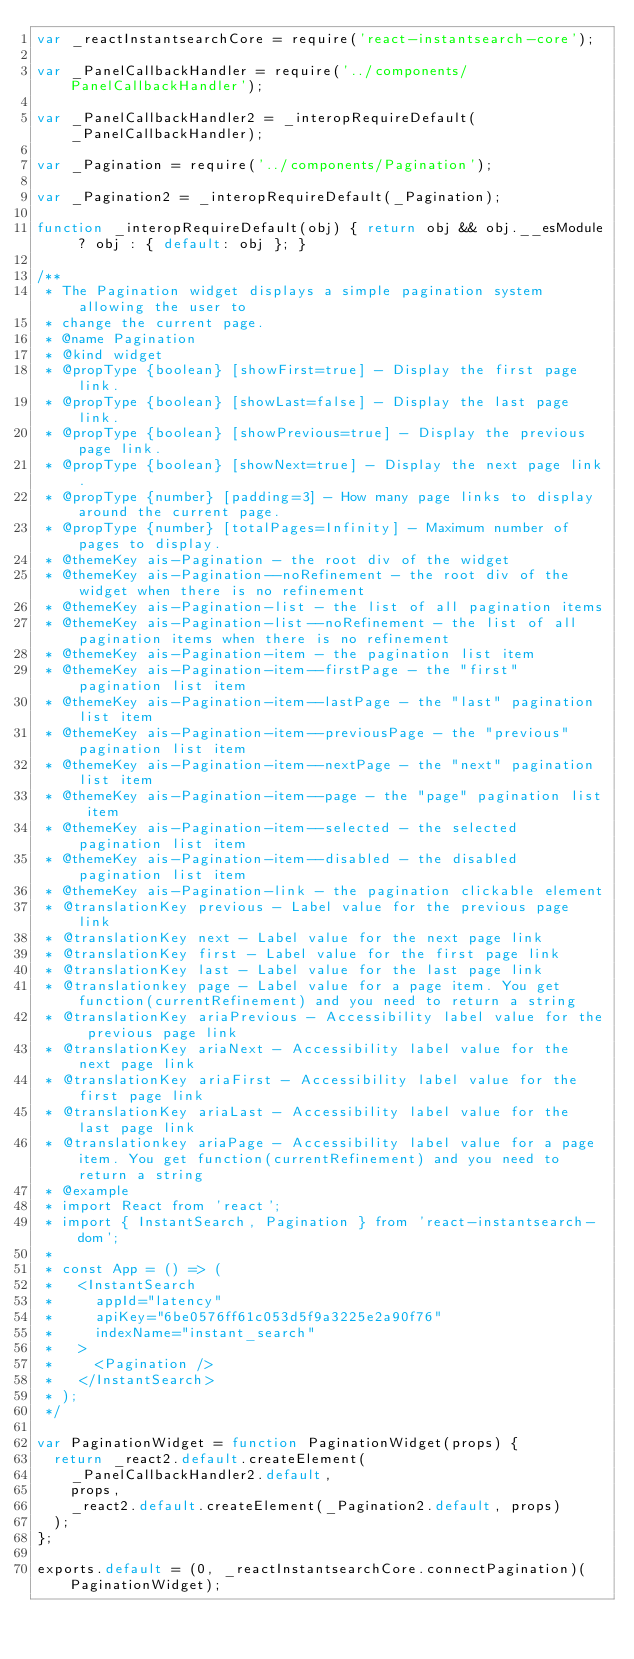Convert code to text. <code><loc_0><loc_0><loc_500><loc_500><_JavaScript_>var _reactInstantsearchCore = require('react-instantsearch-core');

var _PanelCallbackHandler = require('../components/PanelCallbackHandler');

var _PanelCallbackHandler2 = _interopRequireDefault(_PanelCallbackHandler);

var _Pagination = require('../components/Pagination');

var _Pagination2 = _interopRequireDefault(_Pagination);

function _interopRequireDefault(obj) { return obj && obj.__esModule ? obj : { default: obj }; }

/**
 * The Pagination widget displays a simple pagination system allowing the user to
 * change the current page.
 * @name Pagination
 * @kind widget
 * @propType {boolean} [showFirst=true] - Display the first page link.
 * @propType {boolean} [showLast=false] - Display the last page link.
 * @propType {boolean} [showPrevious=true] - Display the previous page link.
 * @propType {boolean} [showNext=true] - Display the next page link.
 * @propType {number} [padding=3] - How many page links to display around the current page.
 * @propType {number} [totalPages=Infinity] - Maximum number of pages to display.
 * @themeKey ais-Pagination - the root div of the widget
 * @themeKey ais-Pagination--noRefinement - the root div of the widget when there is no refinement
 * @themeKey ais-Pagination-list - the list of all pagination items
 * @themeKey ais-Pagination-list--noRefinement - the list of all pagination items when there is no refinement
 * @themeKey ais-Pagination-item - the pagination list item
 * @themeKey ais-Pagination-item--firstPage - the "first" pagination list item
 * @themeKey ais-Pagination-item--lastPage - the "last" pagination list item
 * @themeKey ais-Pagination-item--previousPage - the "previous" pagination list item
 * @themeKey ais-Pagination-item--nextPage - the "next" pagination list item
 * @themeKey ais-Pagination-item--page - the "page" pagination list item
 * @themeKey ais-Pagination-item--selected - the selected pagination list item
 * @themeKey ais-Pagination-item--disabled - the disabled pagination list item
 * @themeKey ais-Pagination-link - the pagination clickable element
 * @translationKey previous - Label value for the previous page link
 * @translationKey next - Label value for the next page link
 * @translationKey first - Label value for the first page link
 * @translationKey last - Label value for the last page link
 * @translationkey page - Label value for a page item. You get function(currentRefinement) and you need to return a string
 * @translationKey ariaPrevious - Accessibility label value for the previous page link
 * @translationKey ariaNext - Accessibility label value for the next page link
 * @translationKey ariaFirst - Accessibility label value for the first page link
 * @translationKey ariaLast - Accessibility label value for the last page link
 * @translationkey ariaPage - Accessibility label value for a page item. You get function(currentRefinement) and you need to return a string
 * @example
 * import React from 'react';
 * import { InstantSearch, Pagination } from 'react-instantsearch-dom';
 *
 * const App = () => (
 *   <InstantSearch
 *     appId="latency"
 *     apiKey="6be0576ff61c053d5f9a3225e2a90f76"
 *     indexName="instant_search"
 *   >
 *     <Pagination />
 *   </InstantSearch>
 * );
 */

var PaginationWidget = function PaginationWidget(props) {
  return _react2.default.createElement(
    _PanelCallbackHandler2.default,
    props,
    _react2.default.createElement(_Pagination2.default, props)
  );
};

exports.default = (0, _reactInstantsearchCore.connectPagination)(PaginationWidget);</code> 